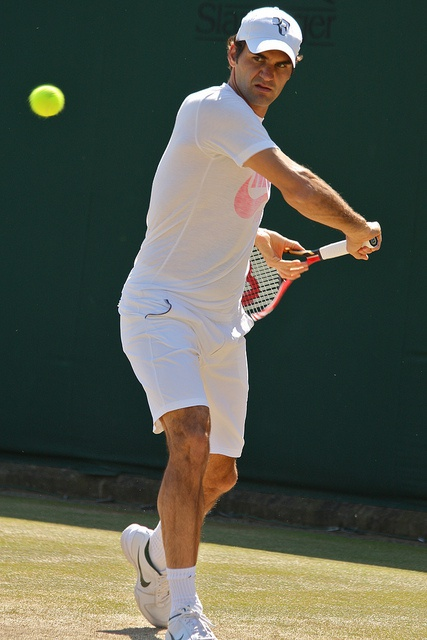Describe the objects in this image and their specific colors. I can see people in black, darkgray, and brown tones, tennis racket in black, darkgray, tan, and gray tones, and sports ball in black, yellow, and khaki tones in this image. 